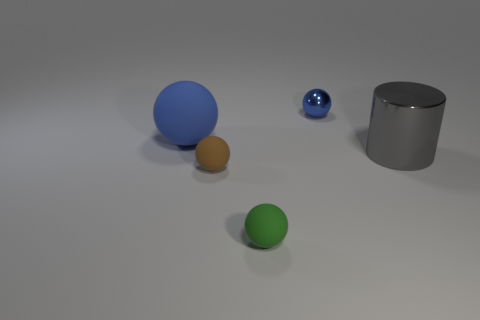What number of other objects are the same material as the gray cylinder?
Keep it short and to the point. 1. What number of tiny matte spheres are there?
Your response must be concise. 2. What material is the small blue object that is the same shape as the small brown object?
Your response must be concise. Metal. Do the green ball left of the big metallic cylinder and the big blue ball have the same material?
Make the answer very short. Yes. Are there more large balls that are behind the large blue object than cylinders that are left of the tiny blue ball?
Provide a succinct answer. No. The blue metal object is what size?
Make the answer very short. Small. There is a tiny blue object that is the same material as the gray object; what is its shape?
Provide a short and direct response. Sphere. There is a shiny object behind the big shiny cylinder; is it the same shape as the brown object?
Your response must be concise. Yes. How many things are tiny purple metal cylinders or small rubber balls?
Keep it short and to the point. 2. What is the tiny ball that is both behind the green object and in front of the blue rubber sphere made of?
Your answer should be very brief. Rubber. 